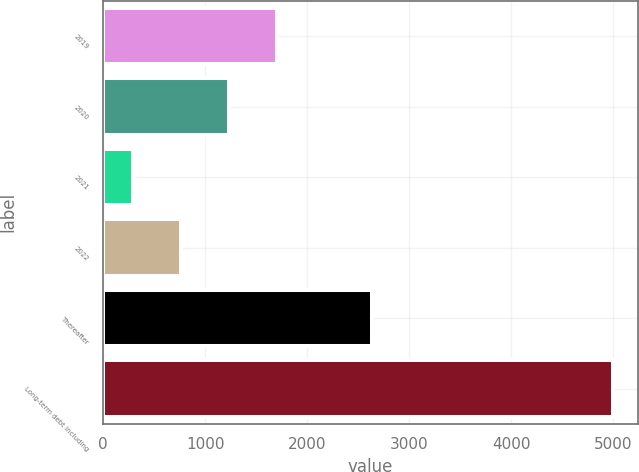Convert chart to OTSL. <chart><loc_0><loc_0><loc_500><loc_500><bar_chart><fcel>2019<fcel>2020<fcel>2021<fcel>2022<fcel>Thereafter<fcel>Long-term debt including<nl><fcel>1706.5<fcel>1237<fcel>298<fcel>767.5<fcel>2632<fcel>4993<nl></chart> 